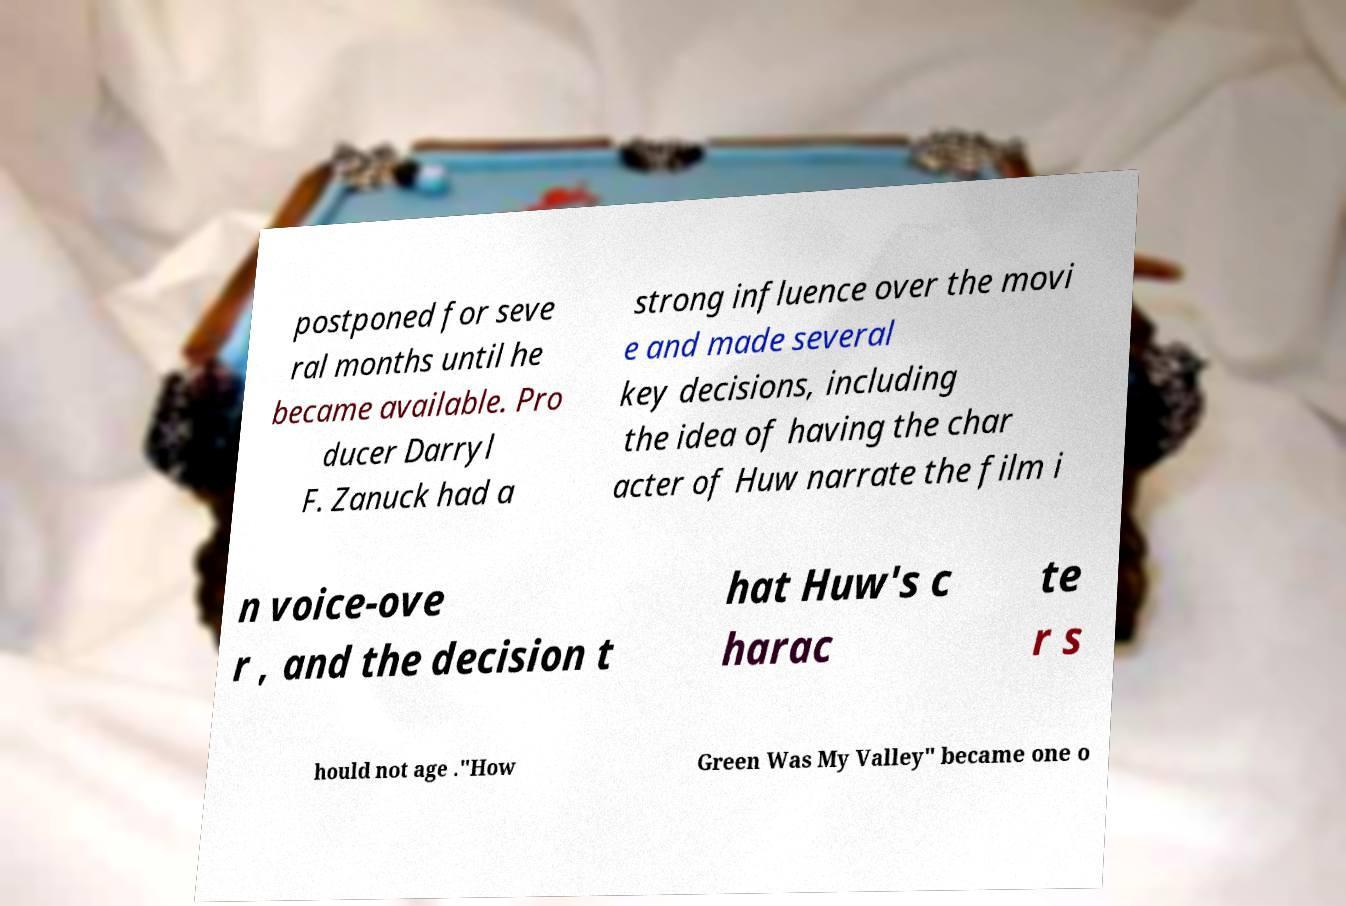What messages or text are displayed in this image? I need them in a readable, typed format. postponed for seve ral months until he became available. Pro ducer Darryl F. Zanuck had a strong influence over the movi e and made several key decisions, including the idea of having the char acter of Huw narrate the film i n voice-ove r , and the decision t hat Huw's c harac te r s hould not age ."How Green Was My Valley" became one o 